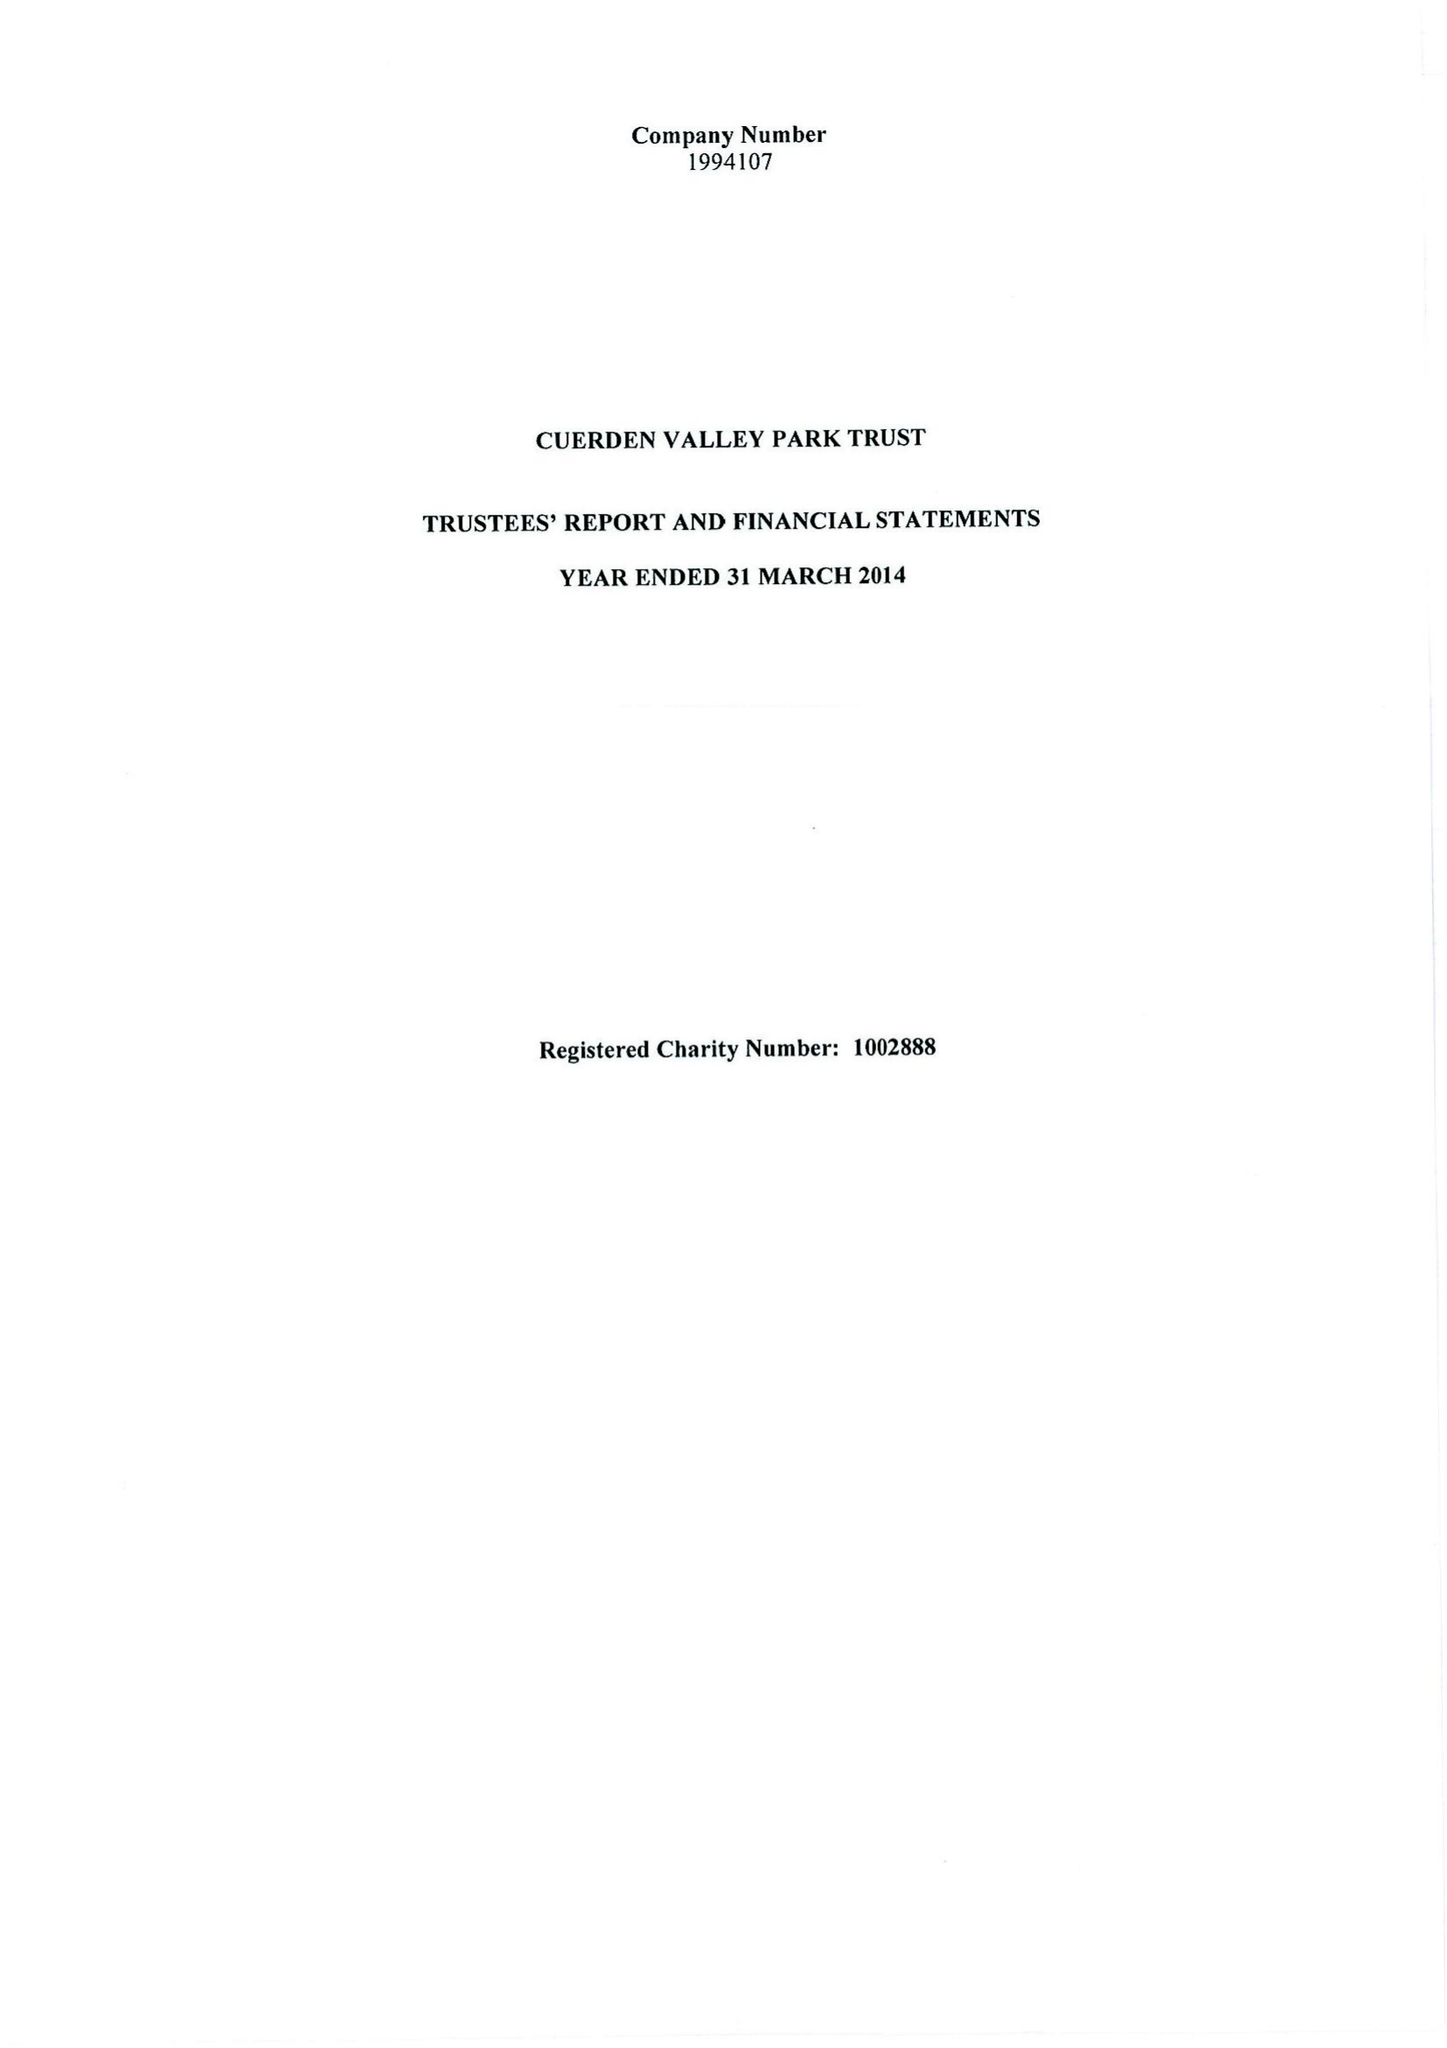What is the value for the address__postcode?
Answer the question using a single word or phrase. PR5 6BY 